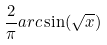<formula> <loc_0><loc_0><loc_500><loc_500>\frac { 2 } { \pi } a r c \sin ( \sqrt { x } )</formula> 